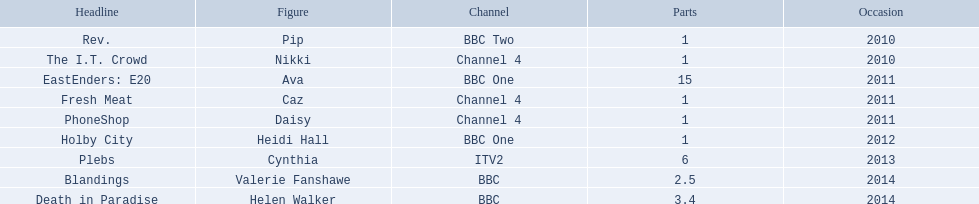How many episodes did sophie colquhoun star in on rev.? 1. What character did she play on phoneshop? Daisy. What role did she play on itv2? Cynthia. 